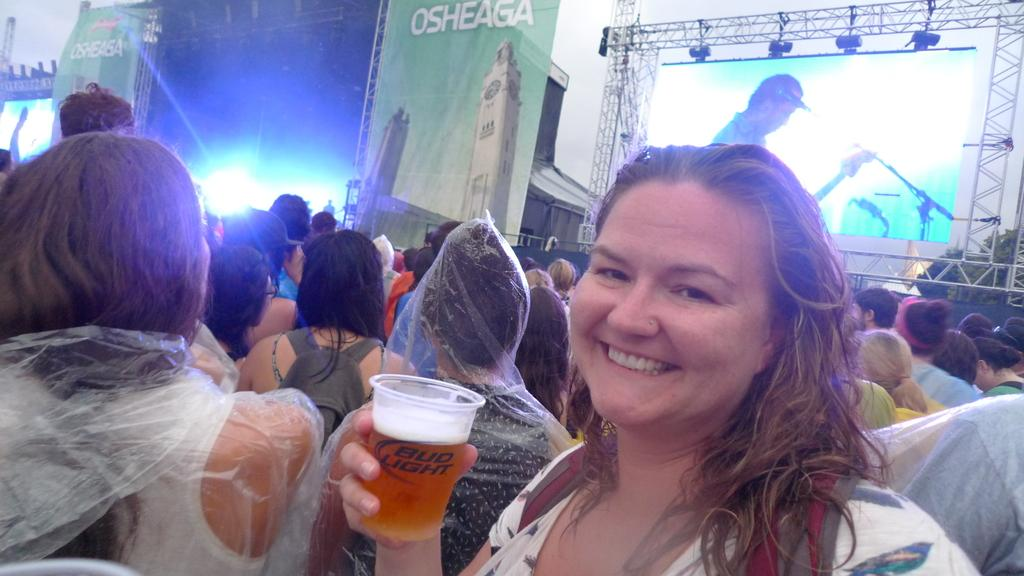What type of event is taking place in the image? The image is from a musical concert. What is the lady holding in her hand? The lady is holding a juice glass in her hand. What can be seen in the background of the image? There is an LCD screen in the background. Can you describe any lighting features in the image? A light is attached to the roof. Are there any icicles hanging from the roof during the concert? There is no mention of icicles in the image, and they are not typically associated with musical concerts. 